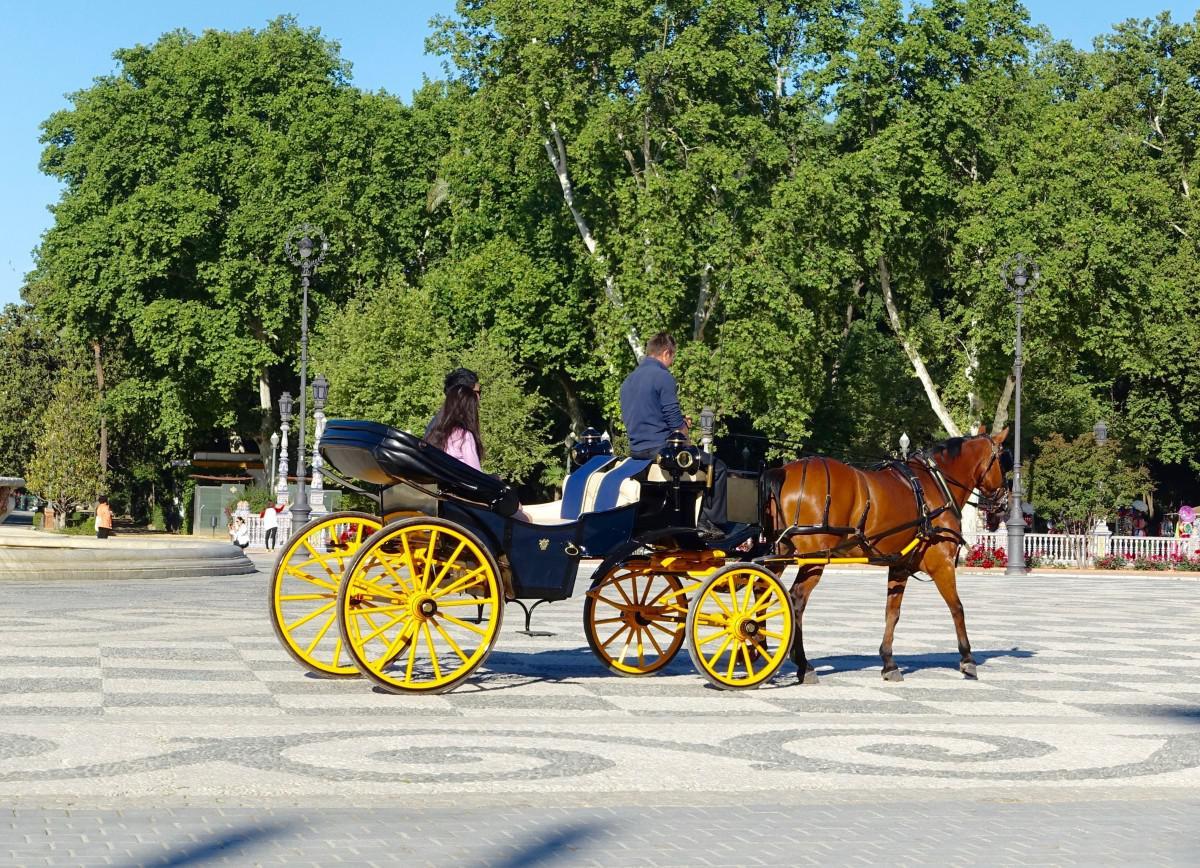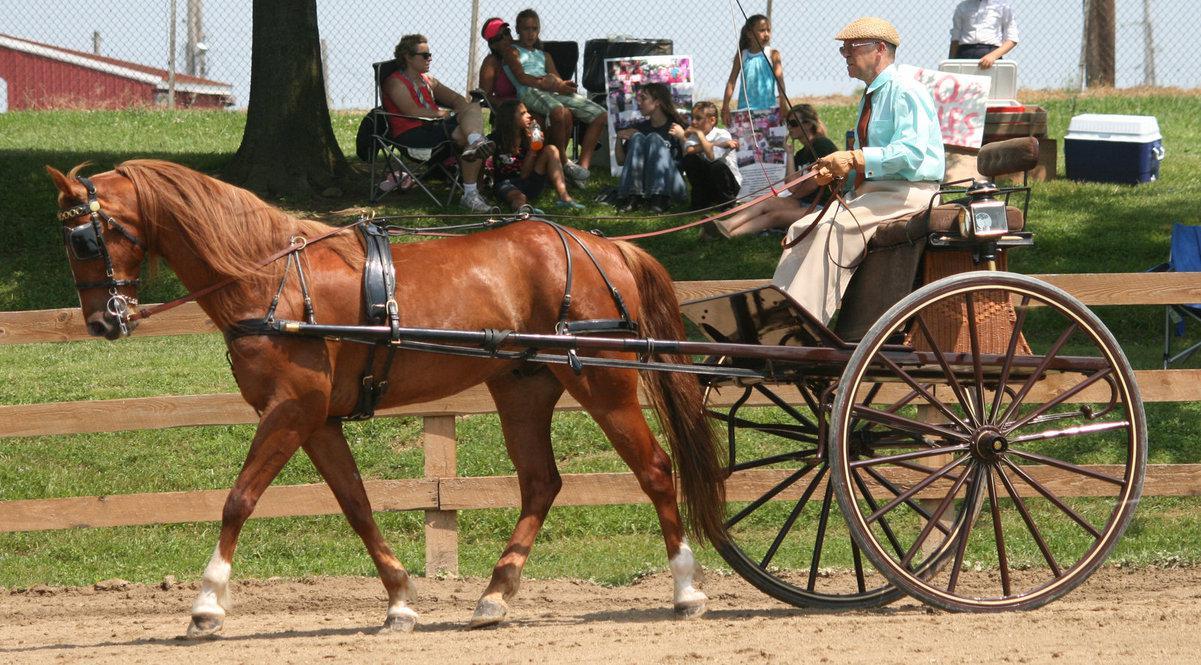The first image is the image on the left, the second image is the image on the right. Given the left and right images, does the statement "The right image shows a passenger in a two-wheeled horse-drawn cart, and the left image shows a passenger-less two-wheeled cart hitched to a horse." hold true? Answer yes or no. No. The first image is the image on the left, the second image is the image on the right. For the images displayed, is the sentence "The left and right image contains the same number of horses pulling a cart in different directions." factually correct? Answer yes or no. Yes. 